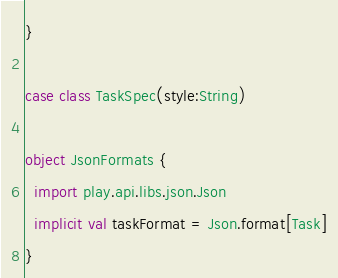<code> <loc_0><loc_0><loc_500><loc_500><_Scala_>}

case class TaskSpec(style:String)

object JsonFormats {
  import play.api.libs.json.Json
  implicit val taskFormat = Json.format[Task]
}</code> 